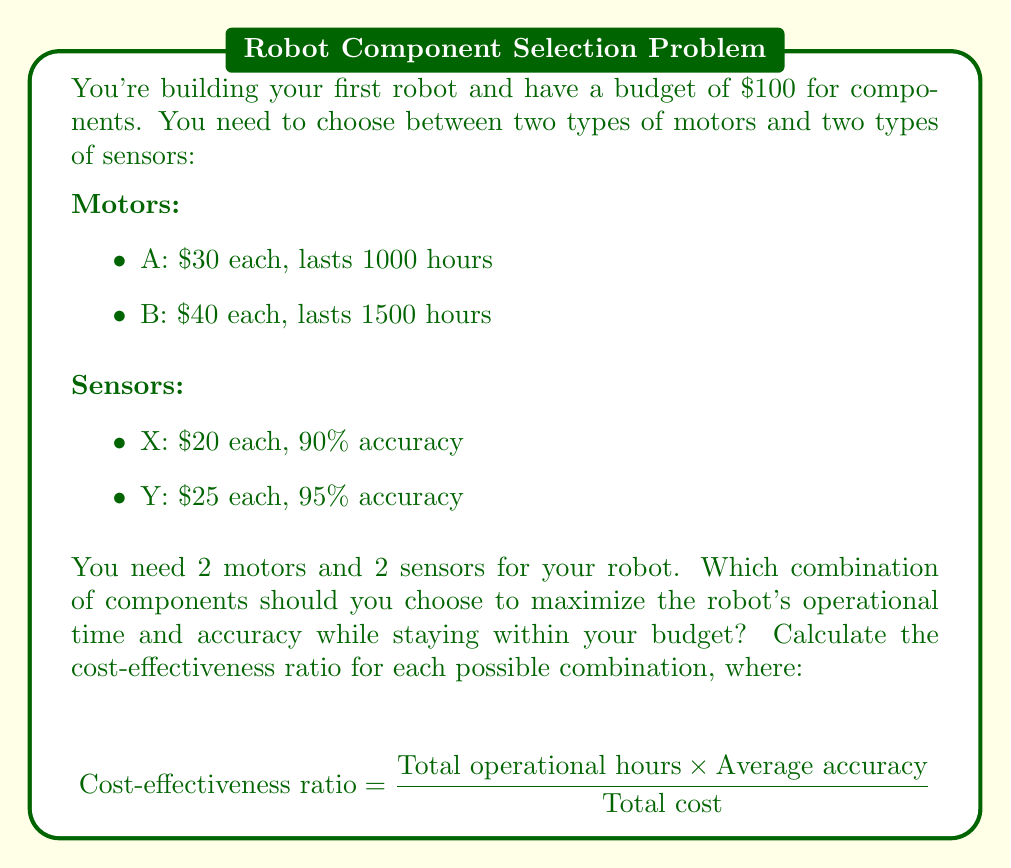Provide a solution to this math problem. Let's approach this step-by-step:

1) First, let's list all possible combinations:
   - A motors + X sensors
   - A motors + Y sensors
   - B motors + X sensors
   - B motors + Y sensors

2) Now, let's calculate the total cost for each combination:
   - A + X: $(30 \times 2) + (20 \times 2) = 60 + 40 = 100$
   - A + Y: $(30 \times 2) + (25 \times 2) = 60 + 50 = 110$ (over budget)
   - B + X: $(40 \times 2) + (20 \times 2) = 80 + 40 = 120$ (over budget)
   - B + Y: $(40 \times 2) + (25 \times 2) = 80 + 50 = 130$ (over budget)

3) We can only consider A + X as it's the only combination within budget.

4) Let's calculate the cost-effectiveness ratio for A + X:
   - Total operational hours: 1000 (since both motors will last 1000 hours)
   - Average accuracy: $(90\% + 90\%) \div 2 = 90\%$ or $0.9$
   - Total cost: $100

   $$ \text{Cost-effectiveness ratio} = \frac{1000 \times 0.9}{100} = 9 $$

Therefore, the cost-effectiveness ratio for the only viable combination (A + X) is 9.
Answer: The best combination is 2 type A motors and 2 type X sensors, with a cost-effectiveness ratio of 9. 